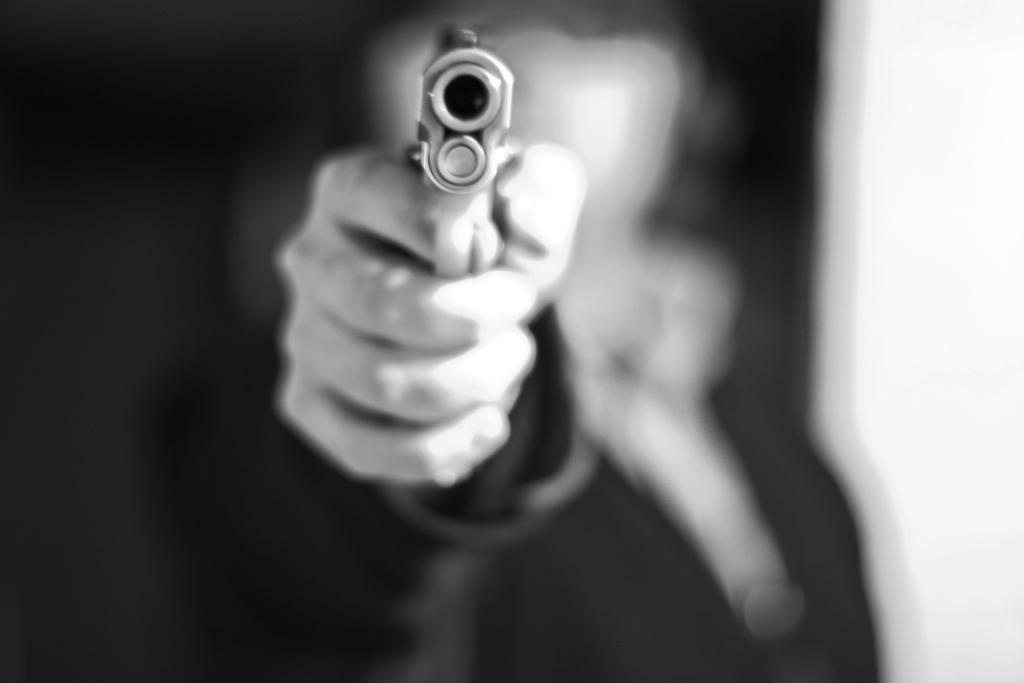What is the person in the image holding? There is a hand holding a gun in the image. Can you describe the background of the image? The background of the image is blurry. What type of belief is being expressed by the can in the image? There is no can present in the image, and therefore no belief can be expressed by it. 